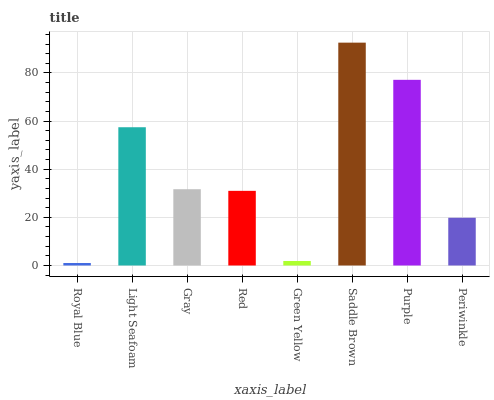Is Light Seafoam the minimum?
Answer yes or no. No. Is Light Seafoam the maximum?
Answer yes or no. No. Is Light Seafoam greater than Royal Blue?
Answer yes or no. Yes. Is Royal Blue less than Light Seafoam?
Answer yes or no. Yes. Is Royal Blue greater than Light Seafoam?
Answer yes or no. No. Is Light Seafoam less than Royal Blue?
Answer yes or no. No. Is Gray the high median?
Answer yes or no. Yes. Is Red the low median?
Answer yes or no. Yes. Is Saddle Brown the high median?
Answer yes or no. No. Is Saddle Brown the low median?
Answer yes or no. No. 